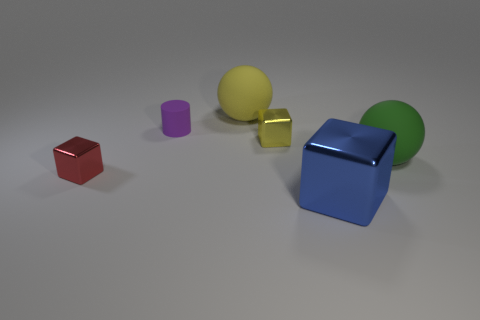How many tiny objects are behind the large green matte ball and in front of the small purple matte cylinder?
Your response must be concise. 1. What is the shape of the yellow thing that is made of the same material as the large blue block?
Your answer should be very brief. Cube. There is a rubber sphere on the left side of the big blue cube; is it the same size as the ball in front of the purple rubber object?
Offer a terse response. Yes. The tiny block behind the tiny red thing is what color?
Keep it short and to the point. Yellow. What is the material of the sphere on the right side of the metallic block in front of the tiny red object?
Offer a very short reply. Rubber. What is the shape of the green thing?
Ensure brevity in your answer.  Sphere. What material is the red object that is the same shape as the big blue object?
Ensure brevity in your answer.  Metal. What number of yellow cubes have the same size as the yellow metal thing?
Provide a succinct answer. 0. Are there any big green matte spheres behind the big matte ball that is on the right side of the big block?
Make the answer very short. No. What number of yellow objects are either big cylinders or tiny cubes?
Provide a short and direct response. 1. 